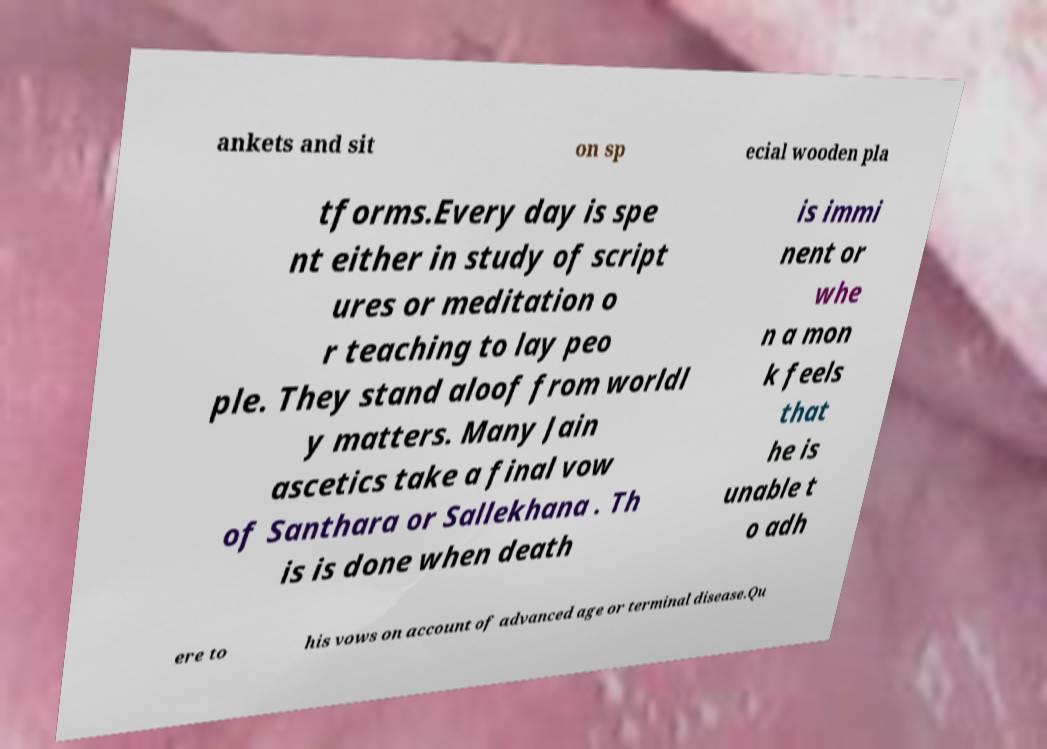Can you accurately transcribe the text from the provided image for me? ankets and sit on sp ecial wooden pla tforms.Every day is spe nt either in study of script ures or meditation o r teaching to lay peo ple. They stand aloof from worldl y matters. Many Jain ascetics take a final vow of Santhara or Sallekhana . Th is is done when death is immi nent or whe n a mon k feels that he is unable t o adh ere to his vows on account of advanced age or terminal disease.Qu 